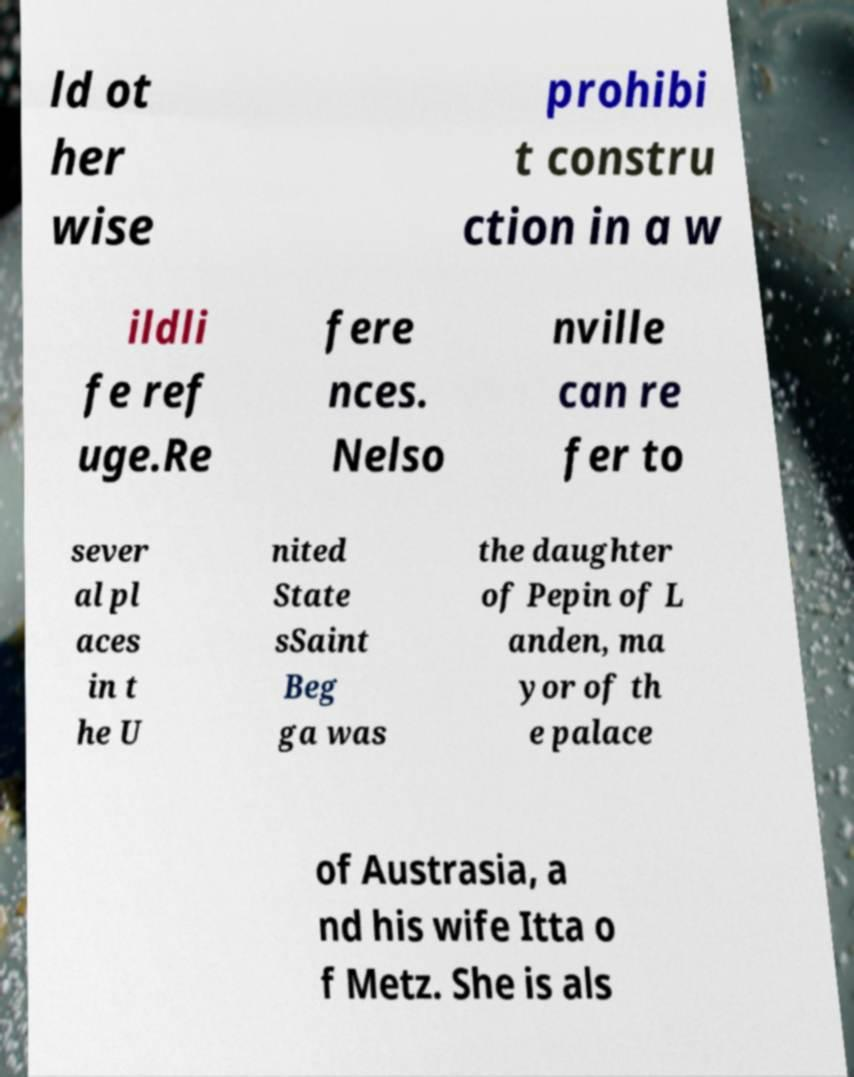Can you read and provide the text displayed in the image?This photo seems to have some interesting text. Can you extract and type it out for me? ld ot her wise prohibi t constru ction in a w ildli fe ref uge.Re fere nces. Nelso nville can re fer to sever al pl aces in t he U nited State sSaint Beg ga was the daughter of Pepin of L anden, ma yor of th e palace of Austrasia, a nd his wife Itta o f Metz. She is als 